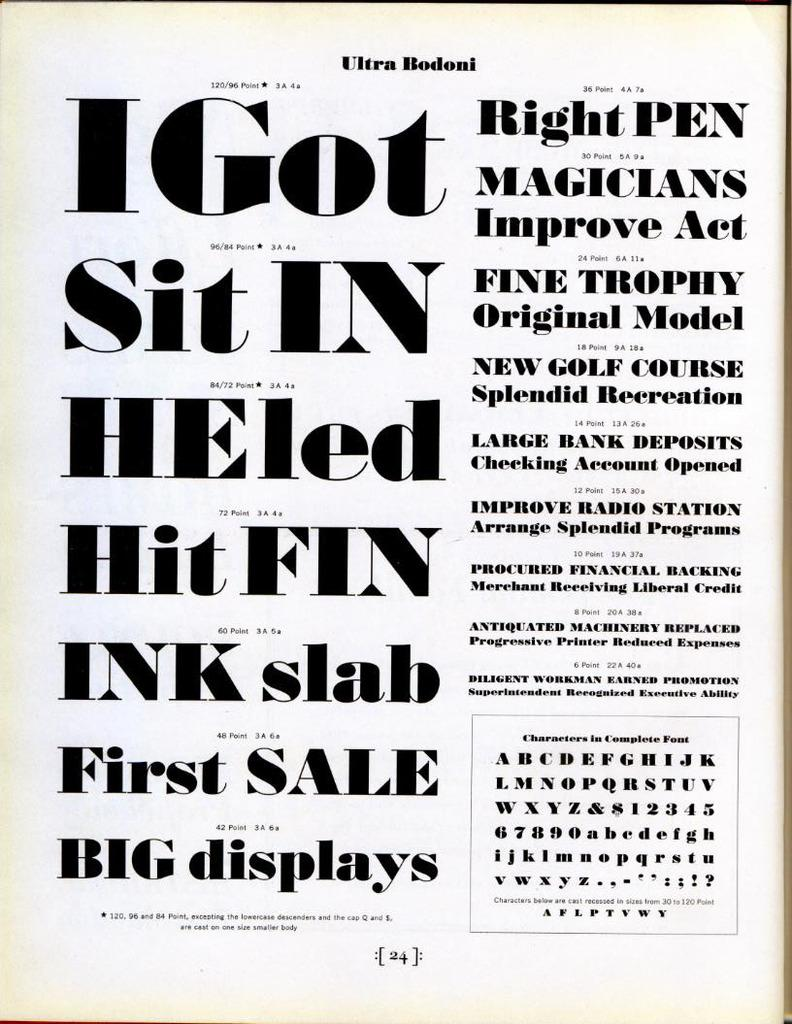<image>
Write a terse but informative summary of the picture. Examples of the Ultra Bodoni font are shown in different sizes. 